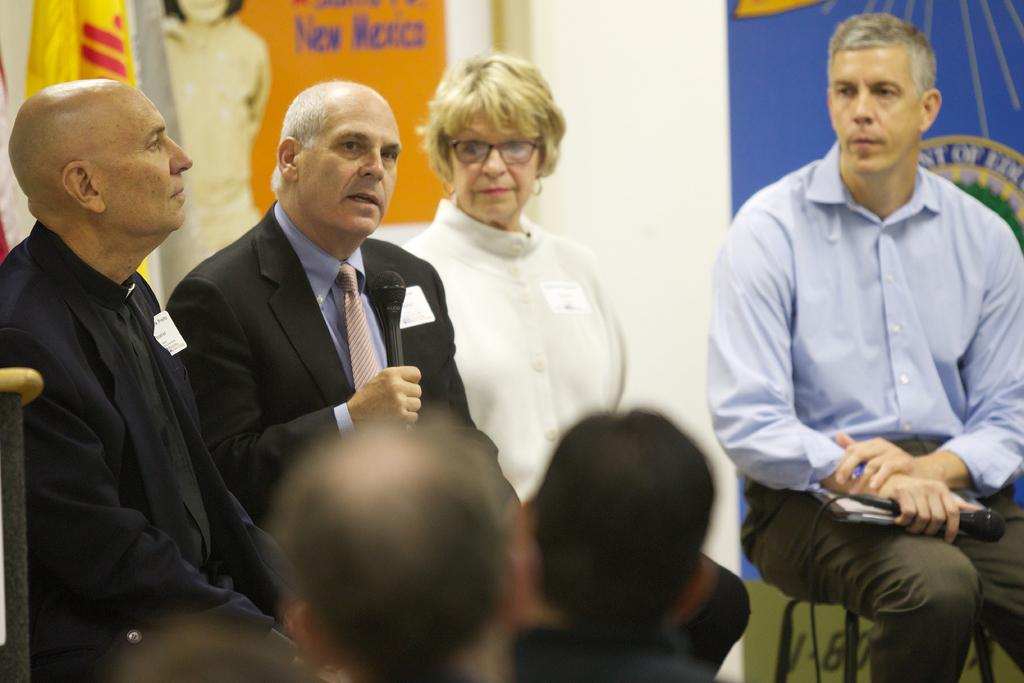How many people are in the image? There is a group of people in the image. What are the people doing in the image? Four people are sitting on chairs. What objects can be seen in the image besides the people? There are boards and walls in the image. What is the flag associated with in the image? There is a flag in the image. How many goldfish are swimming in the water in the image? There are no goldfish or water present in the image. 